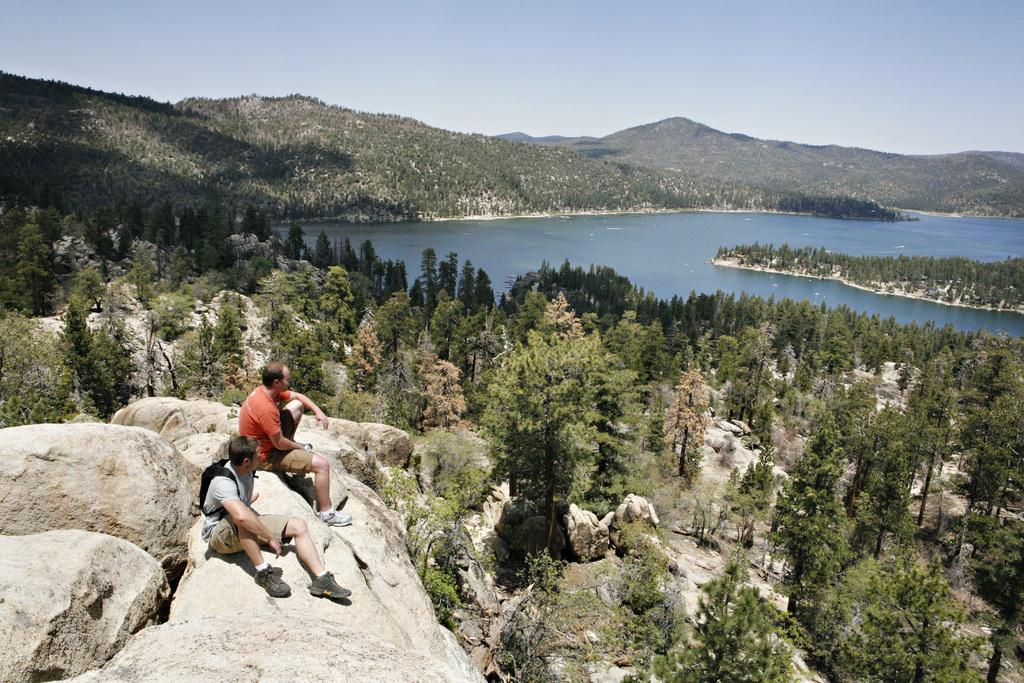How many people are sitting in the image? There are two persons sitting in the image. What can be seen in the image besides the people? There are trees with a green color, water, mountains, and a blue and white sky visible in the image. What type of vegetation is present in the image? Trees are present in the image. What is the color of the sky in the image? The sky is blue and white in color. What type of band is playing in the background of the image? There is no band present in the image; it features two people sitting and a natural landscape in the background. 